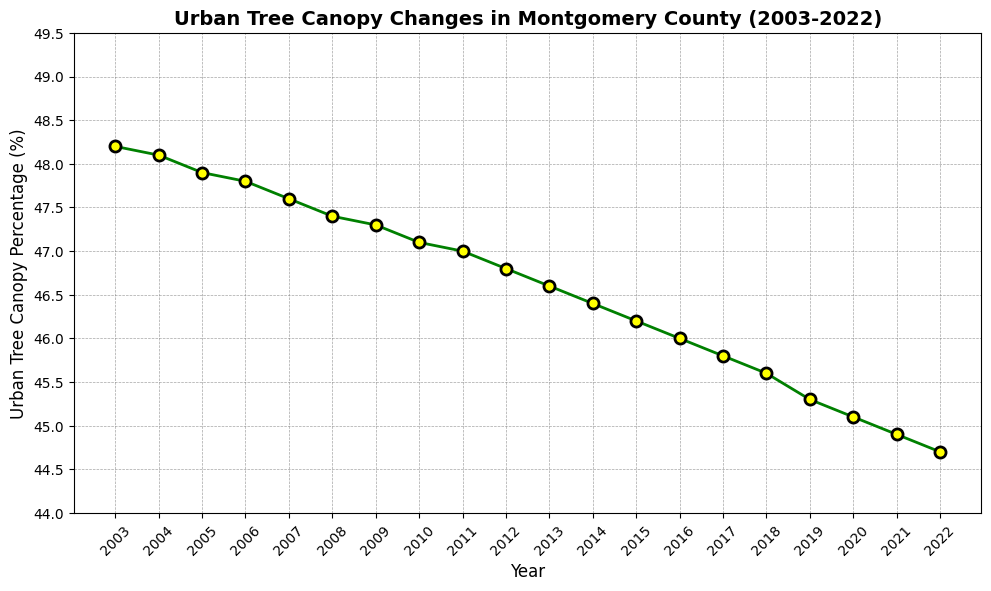Which year had the highest Urban Tree Canopy Percentage? Looking at the line chart, the highest point is in the year 2003 where the Urban Tree Canopy Percentage is at its peak.
Answer: 2003 What is the difference in Urban Tree Canopy Percentage between 2003 and 2022? From the line chart, the Urban Tree Canopy Percentage in 2003 is 48.2 and in 2022 it is 44.7. The difference is 48.2 - 44.7 = 3.5.
Answer: 3.5 In which year did the Urban Tree Canopy Percentage first drop below 47%? As observed from the line chart, the Urban Tree Canopy Percentage first drops below 47% in the year 2011.
Answer: 2011 What was the average Urban Tree Canopy Percentage from 2003 to 2007? The data points from 2003 to 2007 are 48.2, 48.1, 47.9, 47.8, and 47.6. The average is (48.2 + 48.1 + 47.9 + 47.8 + 47.6) / 5 = 47.92.
Answer: 47.92 Which two consecutive years had the steepest decline in Urban Tree Canopy Percentage? The line chart shows the steepest decline occurs between 2003 and 2004, where the decrease is from 48.2 to 48.1, which is a drop of 0.1. Checking all, 2019-2020 with a drop from 45.3 to 45.1 (0.2) is steeper.
Answer: 2019-2020 Between which years was there no change in the Urban Tree Canopy Percentage trend (no increase or decrease)? The line chart shows a consistent trend without any horizontal lines, indicating a continuous decrease in all years.
Answer: None Was the Urban Tree Canopy Percentage ever above 48% after 2003? Referring to the line chart, after 2003 the Urban Tree Canopy Percentage consistently declines and never crosses the 48% mark.
Answer: No 